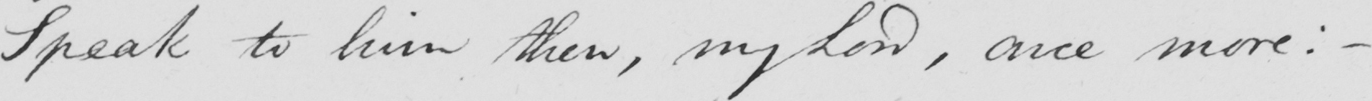Can you tell me what this handwritten text says? Speak to him then, my Lord, once more: _ 